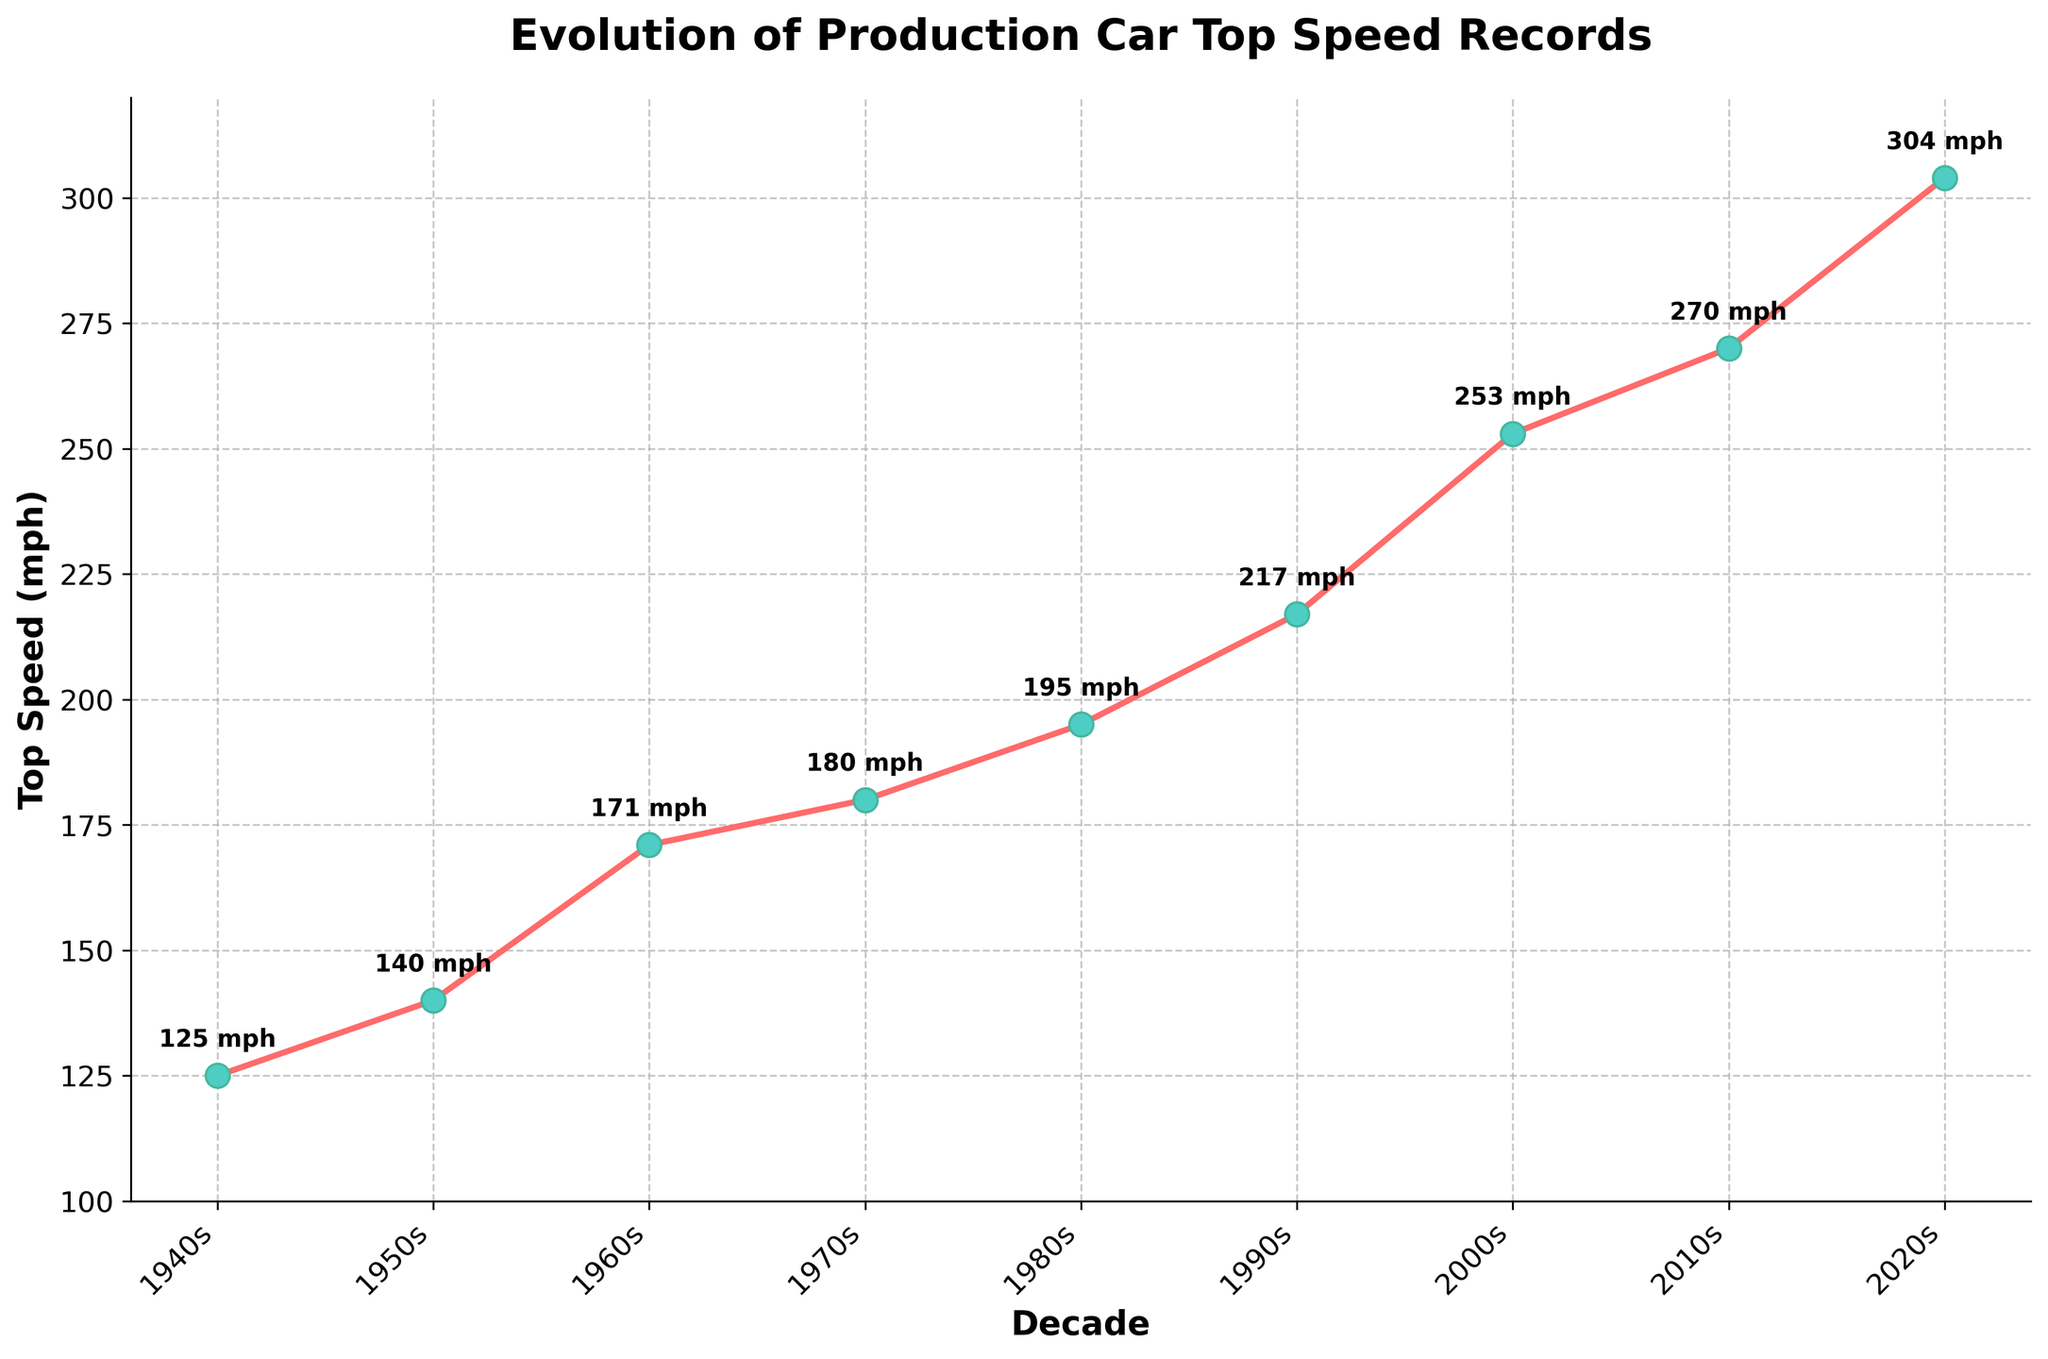Which decade saw the highest increase in top speed compared to the previous one? To find the highest increase, we calculate the difference in top speed between each decade and its previous decade: 1950s-1940s (15 mph), 1960s-1950s (31 mph), 1970s-1960s (9 mph), 1980s-1970s (15 mph), 1990s-1980s (22 mph), 2000s-1990s (36 mph), 2010s-2000s (17 mph), and 2020s-2010s (34 mph). The largest increase occurred between the 1990s and 2000s (36 mph).
Answer: 2000s Which two decades have the smallest difference in top speeds? To determine the smallest difference, we again refer to the differences calculated earlier: 1950s-1940s (15 mph), 1960s-1950s (31 mph), 1970s-1960s (9 mph), 1980s-1970s (15 mph), 1990s-1980s (22 mph), 2000s-1990s (36 mph), 2010s-2000s (17 mph), and 2020s-2010s (34 mph). The smallest difference is between the 1960s and 1970s, which is 9 mph.
Answer: 1960s and 1970s How does the top speed in the 2010s compare to that in the 2000s? The top speed in the 2000s is 253 mph, and in the 2010s it's 270 mph. The difference between them is 270 - 253 = 17 mph. So, the top speed in the 2010s is higher by 17 mph compared to the 2000s.
Answer: 17 mph higher Which decade had the lowest top speed? Looking at the top speeds of each decade: 1940s (125 mph), 1950s (140 mph), 1960s (171 mph), 1970s (180 mph), 1980s (195 mph), 1990s (217 mph), 2000s (253 mph), 2010s (270 mph), and 2020s (304 mph), the 1940s had the lowest top speed at 125 mph.
Answer: 1940s What is the average top speed across all decades presented? To find the average, sum all the top speeds (125 + 140 + 171 + 180 + 195 + 217 + 253 + 270 + 304) which equals 1855. Divide this sum by the number of decades (9): 1855 / 9 ≈ 206.11 mph.
Answer: 206.11 mph How much did the top speed change from the 1940s to the 2020s? The top speed in the 1940s is 125 mph, and in the 2020s it's 304 mph. The difference is 304 - 125 = 179 mph. Therefore, the top speed increased by 179 mph from the 1940s to the 2020s.
Answer: 179 mph Which decade had the highest top speed, and what is that speed? Referring to the top speeds, the 2020s have the highest top speed at 304 mph.
Answer: 2020s, 304 mph How consistent were the top speed increases over the decades? To evaluate consistency, look at the differences between successive decades: 15 mph (1950s-1940s), 31 mph (1960s-1950s), 9 mph (1970s-1960s), 15 mph (1980s-1970s), 22 mph (1990s-1980s), 36 mph (2000s-1990s), 17 mph (2010s-2000s), and 34 mph (2020s-2010s). The differences vary, indicating that the increases were not consistent but fluctuated over decades.
Answer: Fluctuated In which decade did the top speed surpass 200 mph for the first time? Referring to the years and top speeds listed: in the 1990s, the top speed reached 217 mph, which is beyond 200 mph, so the 1990s is the first time the top speed surpassed 200 mph.
Answer: 1990s What is the sum of top speeds from the 1950s to the 1980s? Summing the top speeds for these decades: 140 mph (1950s) + 171 mph (1960s) + 180 mph (1970s) + 195 mph (1980s) = 686 mph.
Answer: 686 mph 